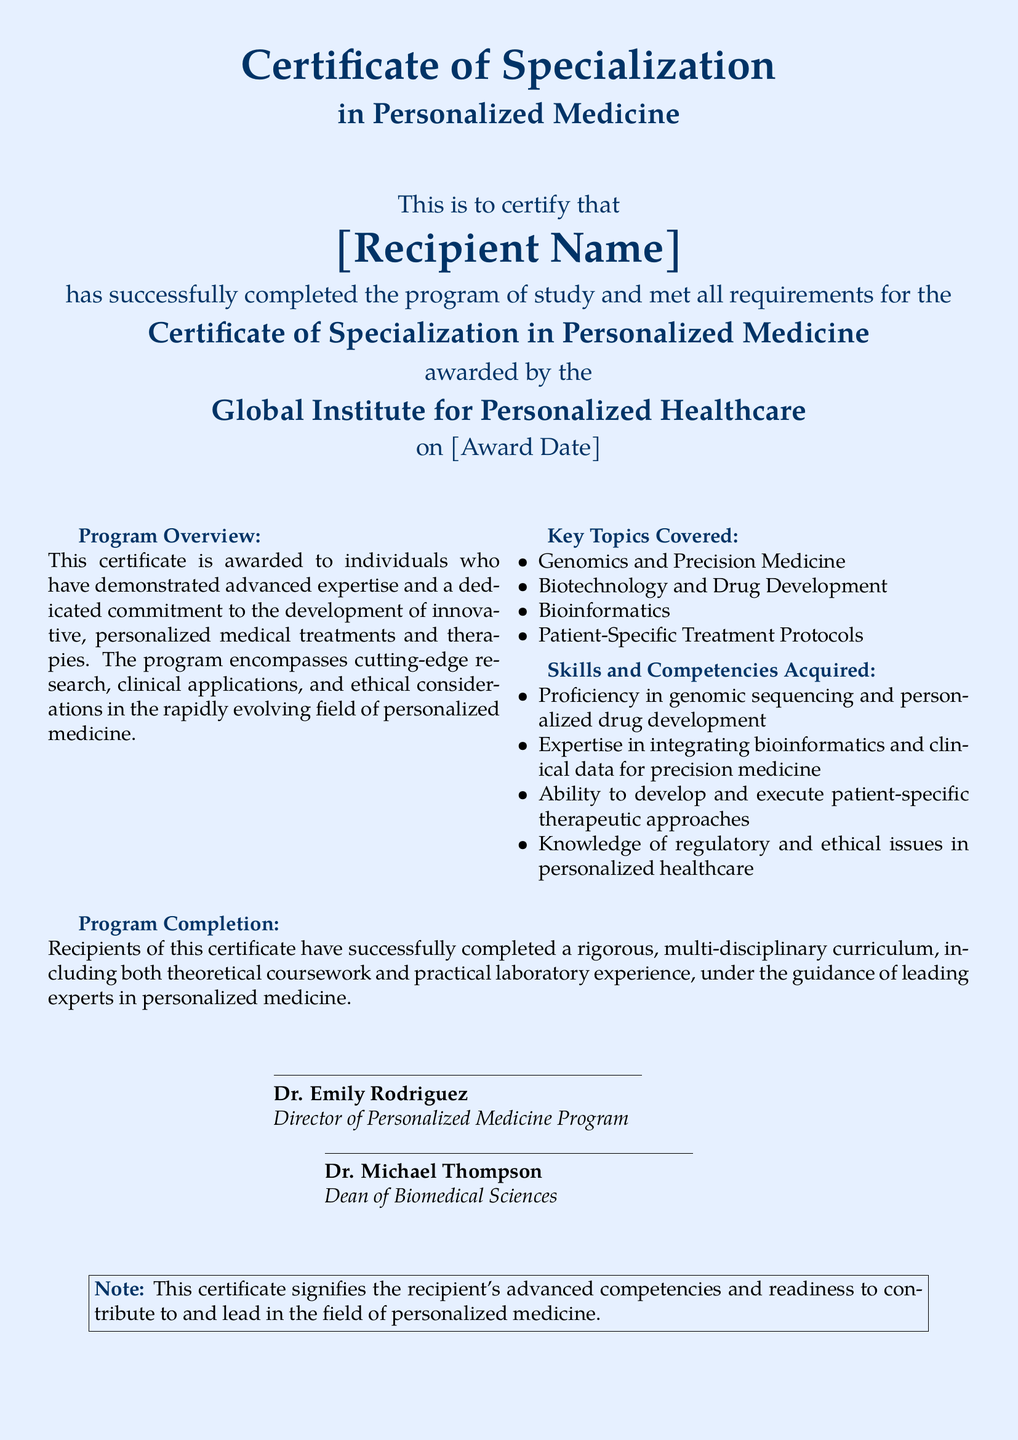What is the title of the certificate? The title of the certificate is presented at the top of the document, emphasizing its focus in a specific field.
Answer: Certificate of Specialization in Personalized Medicine Who is the recipient of the certificate? The document includes a placeholder for the person's name who received the certificate, indicating personalization.
Answer: [Recipient Name] What institution awarded the certificate? The awarding institution is clearly stated, showing the authority and credibility behind the certification.
Answer: Global Institute for Personalized Healthcare What date was the certificate awarded? The document specifies a date placeholder indicating when the certificate was granted to the recipient.
Answer: [Award Date] What are the key topics covered in the program? The document lists several important areas of study within the program, showing the scope of learning.
Answer: Genomics and Precision Medicine, Biotechnology and Drug Development, Bioinformatics, Patient-Specific Treatment Protocols What skills are acquired through the program? The document highlights specific capabilities that graduates will have, underlining the program's practical value.
Answer: Proficiency in genomic sequencing and personalized drug development, Expertise in integrating bioinformatics and clinical data for precision medicine, Ability to develop and execute patient-specific therapeutic approaches, Knowledge of regulatory and ethical issues in personalized healthcare Who are the signatories on the certificate? The individuals who sign the document are key personnel, marking the certificate's legitimacy and their respective roles.
Answer: Dr. Emily Rodriguez, Dr. Michael Thompson What does the note at the bottom of the certificate signify? The note at the bottom sums up the significance of the certificate in relation to the recipient's readiness for the industry.
Answer: Advanced competencies and readiness to contribute to and lead in the field of personalized medicine 